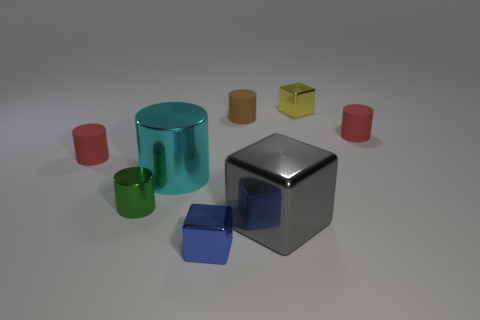Subtract all cyan metallic cylinders. How many cylinders are left? 4 Subtract all red cylinders. How many cylinders are left? 3 Add 1 small green objects. How many objects exist? 9 Subtract 1 cylinders. How many cylinders are left? 4 Subtract all red blocks. Subtract all purple balls. How many blocks are left? 3 Add 8 tiny red rubber objects. How many tiny red rubber objects are left? 10 Add 6 tiny gray shiny objects. How many tiny gray shiny objects exist? 6 Subtract 0 purple balls. How many objects are left? 8 Subtract all cylinders. How many objects are left? 3 Subtract all red cylinders. Subtract all gray shiny things. How many objects are left? 5 